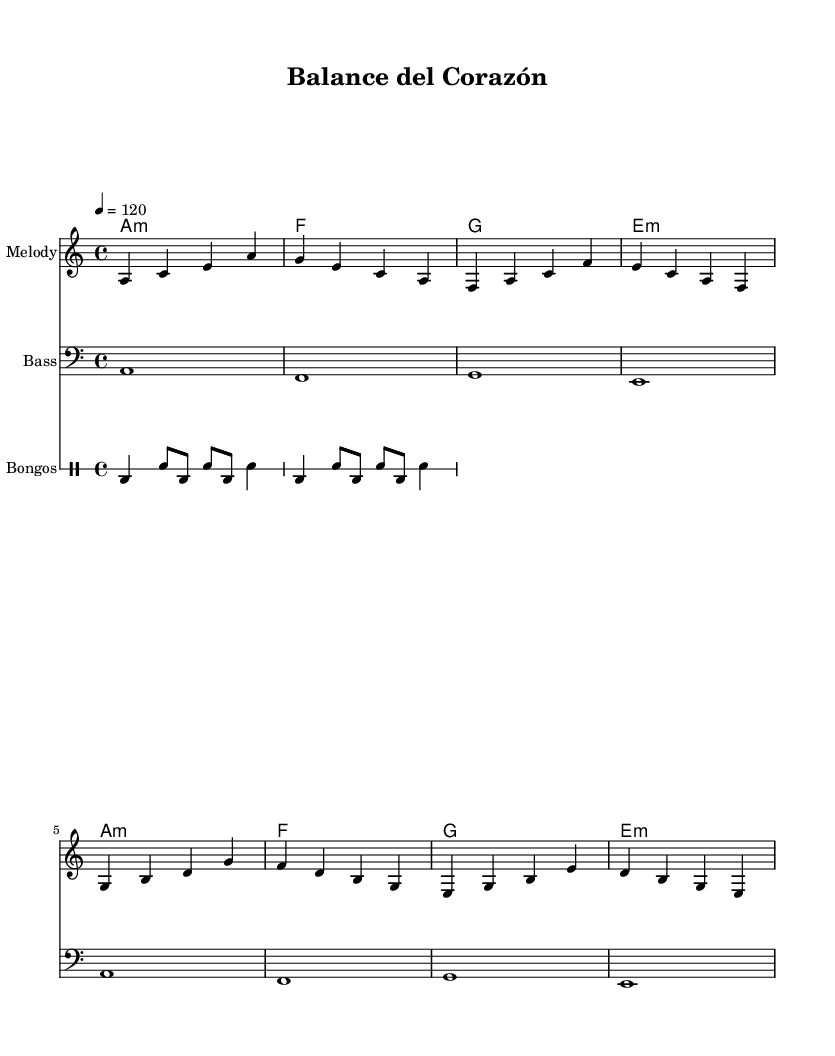What is the key signature of this music? The key signature is A minor, which has no sharps or flats, as indicated by the “\key a \minor” directive in the code.
Answer: A minor What is the time signature of this music? The time signature is 4/4, shown in the code as “\time 4/4,” indicating there are four beats in a measure with a quarter note getting one beat.
Answer: 4/4 What is the tempo marking specified for this piece? The tempo is specified as quarter note equals 120, indicated by “\tempo 4 = 120,” meaning the piece should be played at 120 beats per minute.
Answer: 120 What is the root chord of the first measure? The first measure has an A minor chord, denoted in the harmonies section by “a1:m,” indicating the A minor chord with a bass note sustaining through the measure.
Answer: A minor What rhythmic pattern is used for the bongos? The bongos pattern consists of a combination of bass drum and snare hits, structured with a sequence of beats and rests that defines the rhythm typical in Latin music styles.
Answer: Bass and snare How does the harmony in this piece progress over the bars? The harmony follows a repetitive structure: A minor, F major, G major, and E minor chords in a 2-bar cycle, creating a sense of continuity and balance that reflects the themes of work-life balance.
Answer: A minor, F, G, E minor 